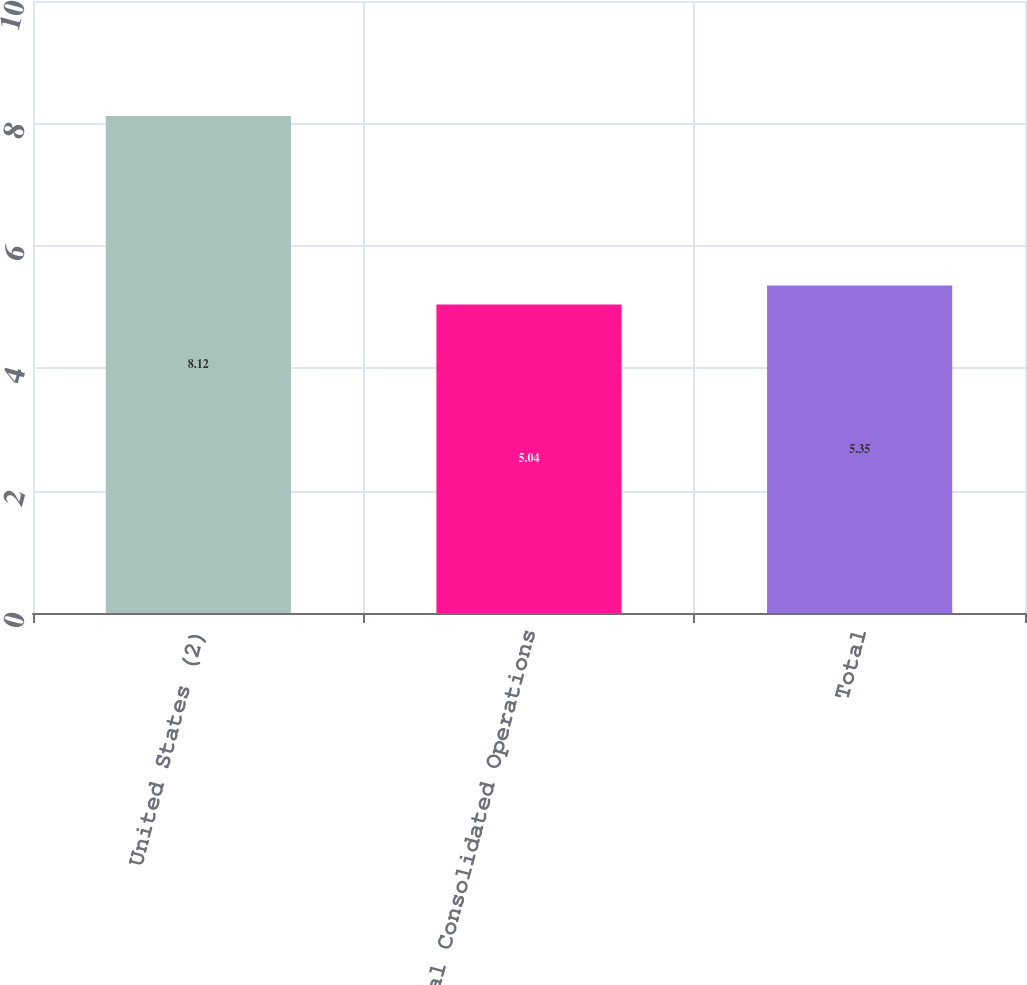Convert chart to OTSL. <chart><loc_0><loc_0><loc_500><loc_500><bar_chart><fcel>United States (2)<fcel>Total Consolidated Operations<fcel>Total<nl><fcel>8.12<fcel>5.04<fcel>5.35<nl></chart> 